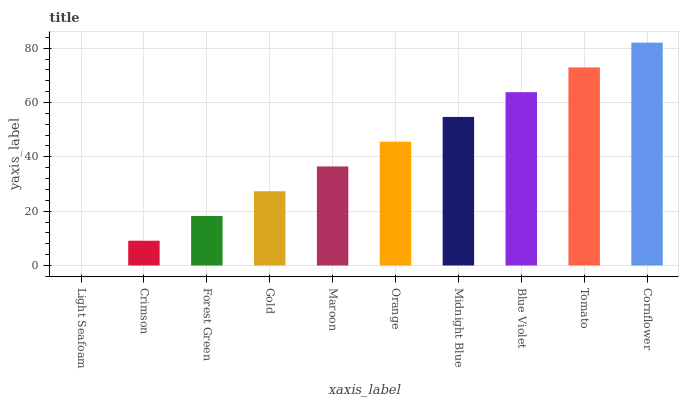Is Light Seafoam the minimum?
Answer yes or no. Yes. Is Cornflower the maximum?
Answer yes or no. Yes. Is Crimson the minimum?
Answer yes or no. No. Is Crimson the maximum?
Answer yes or no. No. Is Crimson greater than Light Seafoam?
Answer yes or no. Yes. Is Light Seafoam less than Crimson?
Answer yes or no. Yes. Is Light Seafoam greater than Crimson?
Answer yes or no. No. Is Crimson less than Light Seafoam?
Answer yes or no. No. Is Orange the high median?
Answer yes or no. Yes. Is Maroon the low median?
Answer yes or no. Yes. Is Gold the high median?
Answer yes or no. No. Is Light Seafoam the low median?
Answer yes or no. No. 